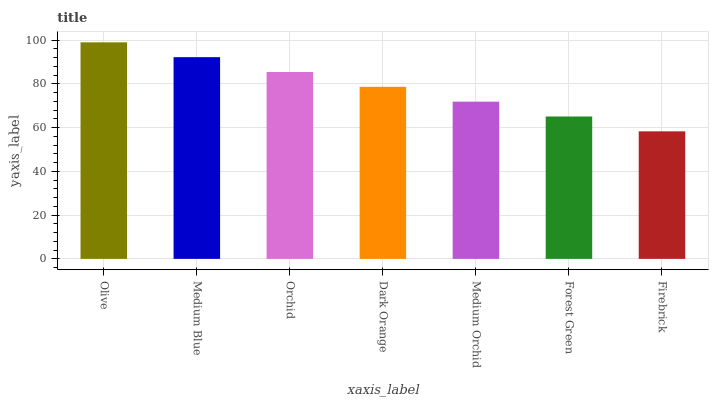Is Firebrick the minimum?
Answer yes or no. Yes. Is Olive the maximum?
Answer yes or no. Yes. Is Medium Blue the minimum?
Answer yes or no. No. Is Medium Blue the maximum?
Answer yes or no. No. Is Olive greater than Medium Blue?
Answer yes or no. Yes. Is Medium Blue less than Olive?
Answer yes or no. Yes. Is Medium Blue greater than Olive?
Answer yes or no. No. Is Olive less than Medium Blue?
Answer yes or no. No. Is Dark Orange the high median?
Answer yes or no. Yes. Is Dark Orange the low median?
Answer yes or no. Yes. Is Forest Green the high median?
Answer yes or no. No. Is Medium Blue the low median?
Answer yes or no. No. 